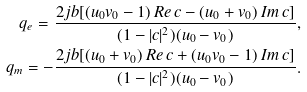<formula> <loc_0><loc_0><loc_500><loc_500>q _ { e } = \frac { 2 j b [ ( u _ { 0 } v _ { 0 } - 1 ) \, R e \, c - ( u _ { 0 } + v _ { 0 } ) \, I m \, c ] } { ( 1 - | c | ^ { 2 } ) ( u _ { 0 } - v _ { 0 } ) } , \\ q _ { m } = - \frac { 2 j b [ ( u _ { 0 } + v _ { 0 } ) \, R e \, c + ( u _ { 0 } v _ { 0 } - 1 ) \, I m \, c ] } { ( 1 - | c | ^ { 2 } ) ( u _ { 0 } - v _ { 0 } ) } .</formula> 